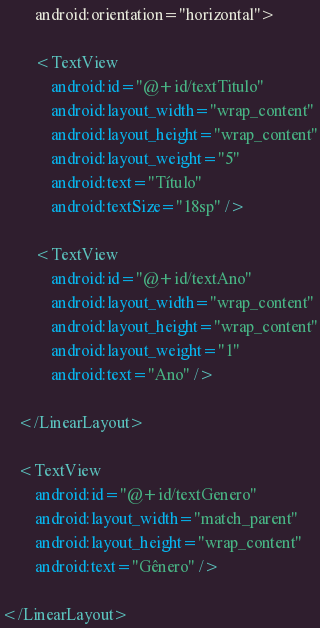Convert code to text. <code><loc_0><loc_0><loc_500><loc_500><_XML_>        android:orientation="horizontal">

        <TextView
            android:id="@+id/textTitulo"
            android:layout_width="wrap_content"
            android:layout_height="wrap_content"
            android:layout_weight="5"
            android:text="Título"
            android:textSize="18sp" />

        <TextView
            android:id="@+id/textAno"
            android:layout_width="wrap_content"
            android:layout_height="wrap_content"
            android:layout_weight="1"
            android:text="Ano" />

    </LinearLayout>

    <TextView
        android:id="@+id/textGenero"
        android:layout_width="match_parent"
        android:layout_height="wrap_content"
        android:text="Gênero" />

</LinearLayout></code> 